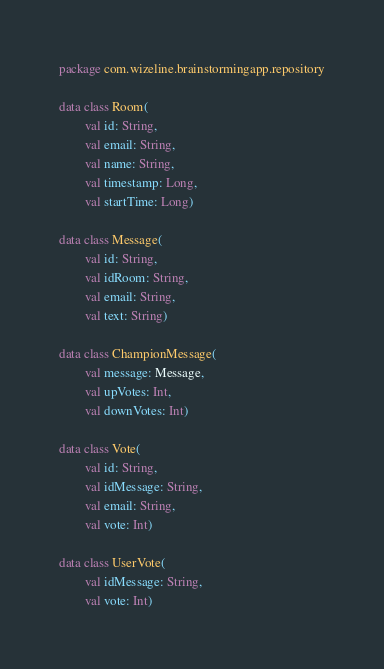<code> <loc_0><loc_0><loc_500><loc_500><_Kotlin_>package com.wizeline.brainstormingapp.repository

data class Room(
        val id: String,
        val email: String,
        val name: String,
        val timestamp: Long,
        val startTime: Long)

data class Message(
        val id: String,
        val idRoom: String,
        val email: String,
        val text: String)

data class ChampionMessage(
        val message: Message,
        val upVotes: Int,
        val downVotes: Int)

data class Vote(
        val id: String,
        val idMessage: String,
        val email: String,
        val vote: Int)

data class UserVote(
        val idMessage: String,
        val vote: Int)
</code> 